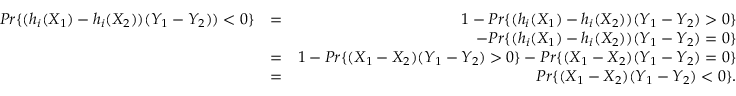Convert formula to latex. <formula><loc_0><loc_0><loc_500><loc_500>\begin{array} { r l r } { P r \{ ( h _ { i } ( X _ { 1 } ) - h _ { i } ( X _ { 2 } ) ) ( Y _ { 1 } - Y _ { 2 } ) ) < 0 \} } & { = } & { 1 - P r \{ ( h _ { i } ( X _ { 1 } ) - h _ { i } ( X _ { 2 } ) ) ( Y _ { 1 } - Y _ { 2 } ) > 0 \} } \\ & { - P r \{ ( h _ { i } ( X _ { 1 } ) - h _ { i } ( X _ { 2 } ) ) ( Y _ { 1 } - Y _ { 2 } ) = 0 \} } \\ & { = } & { 1 - P r \{ ( X _ { 1 } - X _ { 2 } ) ( Y _ { 1 } - Y _ { 2 } ) > 0 \} - P r \{ ( X _ { 1 } - X _ { 2 } ) ( Y _ { 1 } - Y _ { 2 } ) = 0 \} } \\ & { = } & { P r \{ ( X _ { 1 } - X _ { 2 } ) ( Y _ { 1 } - Y _ { 2 } ) < 0 \} . } \end{array}</formula> 